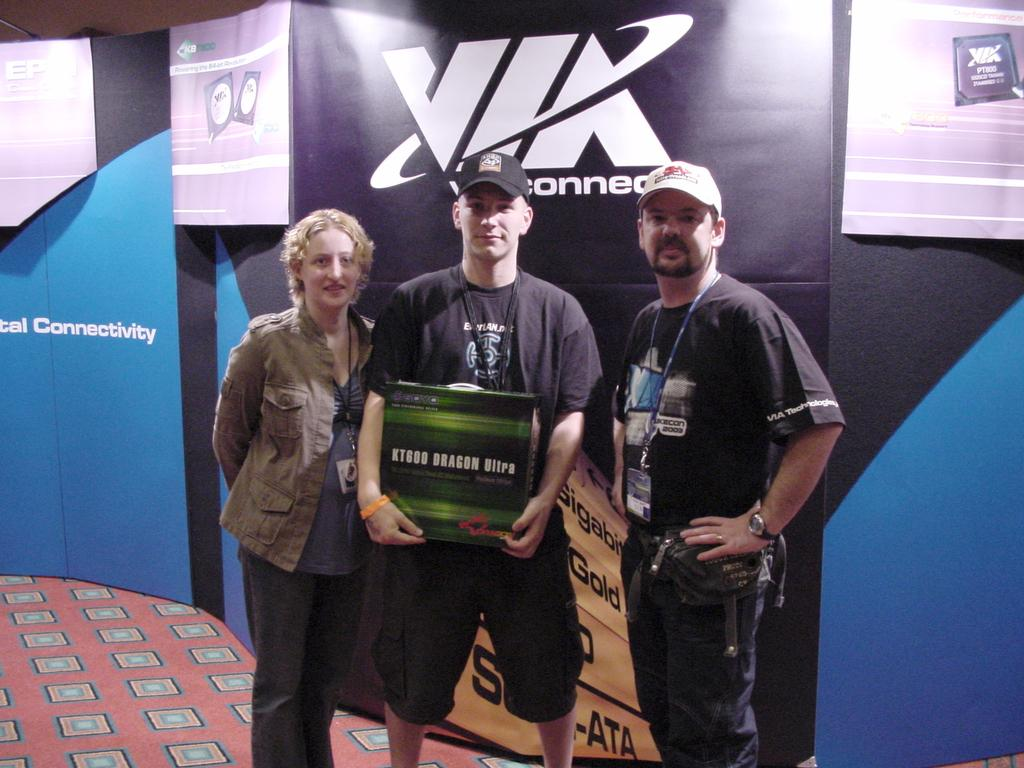How many people are in the image? There are three persons standing in the center of the image. What can be seen in the background of the image? There is an advertisement board in the background of the image. What is at the bottom of the image? There is a carpet at the bottom of the image. What type of lace is draped over the sofa in the image? There is no sofa or lace present in the image. 